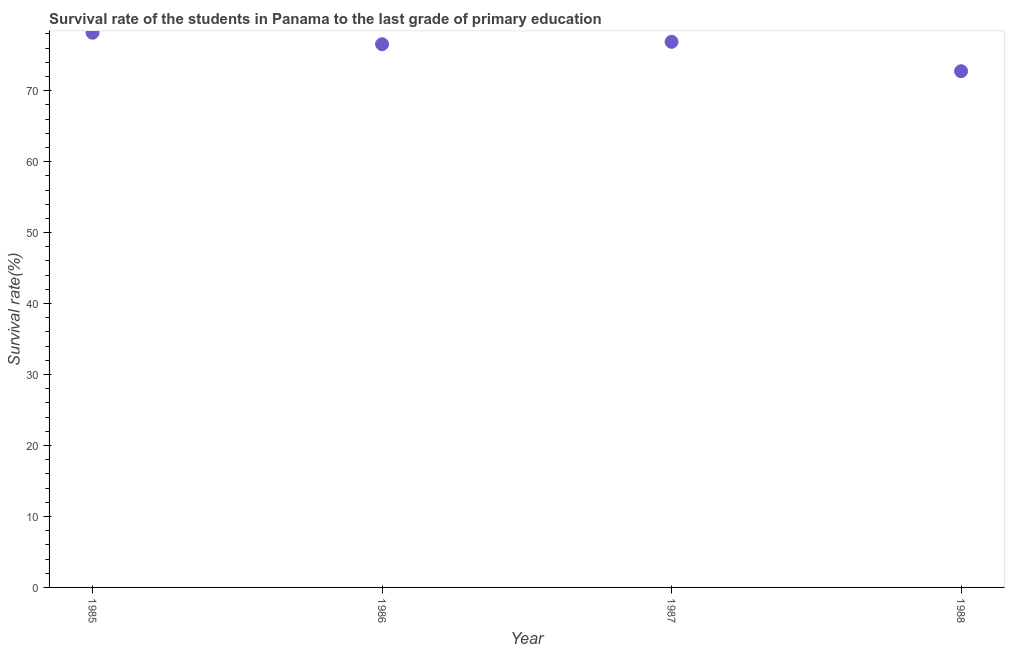What is the survival rate in primary education in 1986?
Keep it short and to the point. 76.54. Across all years, what is the maximum survival rate in primary education?
Offer a terse response. 78.16. Across all years, what is the minimum survival rate in primary education?
Ensure brevity in your answer.  72.74. In which year was the survival rate in primary education maximum?
Keep it short and to the point. 1985. What is the sum of the survival rate in primary education?
Give a very brief answer. 304.32. What is the difference between the survival rate in primary education in 1985 and 1987?
Provide a succinct answer. 1.28. What is the average survival rate in primary education per year?
Keep it short and to the point. 76.08. What is the median survival rate in primary education?
Your answer should be compact. 76.71. Do a majority of the years between 1986 and 1988 (inclusive) have survival rate in primary education greater than 74 %?
Your answer should be very brief. Yes. What is the ratio of the survival rate in primary education in 1987 to that in 1988?
Keep it short and to the point. 1.06. Is the survival rate in primary education in 1985 less than that in 1986?
Make the answer very short. No. What is the difference between the highest and the second highest survival rate in primary education?
Provide a succinct answer. 1.28. Is the sum of the survival rate in primary education in 1986 and 1987 greater than the maximum survival rate in primary education across all years?
Your answer should be compact. Yes. What is the difference between the highest and the lowest survival rate in primary education?
Your answer should be compact. 5.42. In how many years, is the survival rate in primary education greater than the average survival rate in primary education taken over all years?
Your response must be concise. 3. How many dotlines are there?
Offer a terse response. 1. What is the title of the graph?
Provide a succinct answer. Survival rate of the students in Panama to the last grade of primary education. What is the label or title of the X-axis?
Keep it short and to the point. Year. What is the label or title of the Y-axis?
Your answer should be very brief. Survival rate(%). What is the Survival rate(%) in 1985?
Offer a very short reply. 78.16. What is the Survival rate(%) in 1986?
Your answer should be compact. 76.54. What is the Survival rate(%) in 1987?
Your answer should be compact. 76.88. What is the Survival rate(%) in 1988?
Ensure brevity in your answer.  72.74. What is the difference between the Survival rate(%) in 1985 and 1986?
Keep it short and to the point. 1.62. What is the difference between the Survival rate(%) in 1985 and 1987?
Offer a terse response. 1.28. What is the difference between the Survival rate(%) in 1985 and 1988?
Ensure brevity in your answer.  5.42. What is the difference between the Survival rate(%) in 1986 and 1987?
Provide a short and direct response. -0.34. What is the difference between the Survival rate(%) in 1986 and 1988?
Your answer should be compact. 3.8. What is the difference between the Survival rate(%) in 1987 and 1988?
Your response must be concise. 4.14. What is the ratio of the Survival rate(%) in 1985 to that in 1986?
Your response must be concise. 1.02. What is the ratio of the Survival rate(%) in 1985 to that in 1987?
Your answer should be very brief. 1.02. What is the ratio of the Survival rate(%) in 1985 to that in 1988?
Provide a succinct answer. 1.07. What is the ratio of the Survival rate(%) in 1986 to that in 1988?
Provide a succinct answer. 1.05. What is the ratio of the Survival rate(%) in 1987 to that in 1988?
Keep it short and to the point. 1.06. 